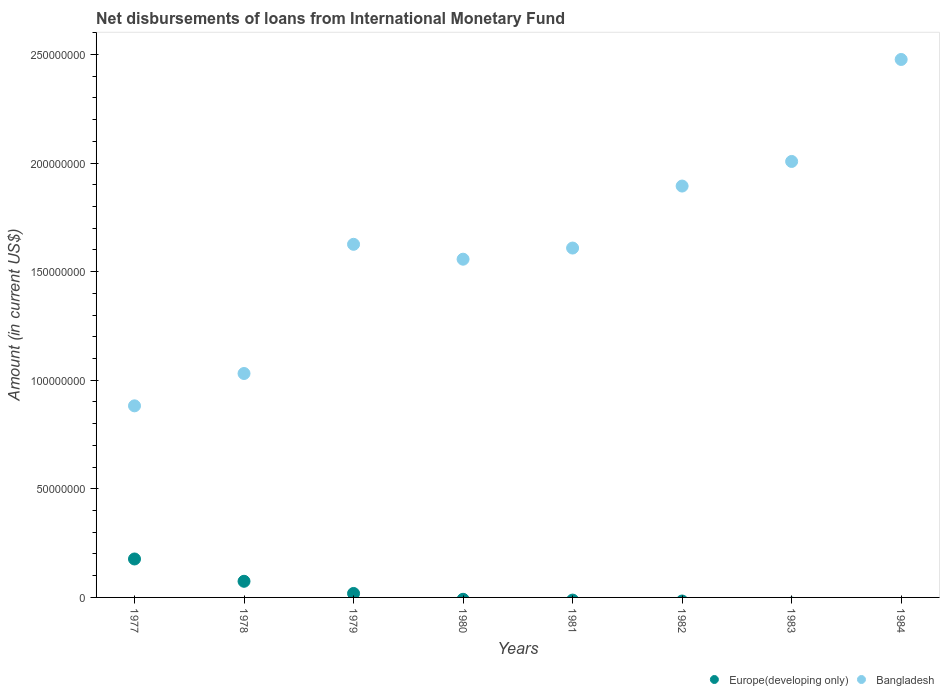How many different coloured dotlines are there?
Keep it short and to the point. 2. Is the number of dotlines equal to the number of legend labels?
Give a very brief answer. No. Across all years, what is the maximum amount of loans disbursed in Bangladesh?
Your answer should be compact. 2.48e+08. In which year was the amount of loans disbursed in Europe(developing only) maximum?
Ensure brevity in your answer.  1977. What is the total amount of loans disbursed in Europe(developing only) in the graph?
Your answer should be compact. 2.70e+07. What is the difference between the amount of loans disbursed in Bangladesh in 1977 and that in 1983?
Your response must be concise. -1.13e+08. What is the difference between the amount of loans disbursed in Bangladesh in 1984 and the amount of loans disbursed in Europe(developing only) in 1979?
Make the answer very short. 2.46e+08. What is the average amount of loans disbursed in Europe(developing only) per year?
Offer a terse response. 3.37e+06. In the year 1979, what is the difference between the amount of loans disbursed in Bangladesh and amount of loans disbursed in Europe(developing only)?
Provide a succinct answer. 1.61e+08. What is the ratio of the amount of loans disbursed in Bangladesh in 1979 to that in 1982?
Your answer should be compact. 0.86. What is the difference between the highest and the second highest amount of loans disbursed in Europe(developing only)?
Offer a very short reply. 1.03e+07. What is the difference between the highest and the lowest amount of loans disbursed in Bangladesh?
Provide a short and direct response. 1.59e+08. Does the amount of loans disbursed in Europe(developing only) monotonically increase over the years?
Offer a very short reply. No. Is the amount of loans disbursed in Europe(developing only) strictly greater than the amount of loans disbursed in Bangladesh over the years?
Your answer should be very brief. No. How many dotlines are there?
Your response must be concise. 2. Does the graph contain any zero values?
Offer a very short reply. Yes. Where does the legend appear in the graph?
Keep it short and to the point. Bottom right. What is the title of the graph?
Offer a terse response. Net disbursements of loans from International Monetary Fund. Does "Samoa" appear as one of the legend labels in the graph?
Your answer should be compact. No. What is the label or title of the X-axis?
Your response must be concise. Years. What is the Amount (in current US$) in Europe(developing only) in 1977?
Keep it short and to the point. 1.77e+07. What is the Amount (in current US$) of Bangladesh in 1977?
Provide a short and direct response. 8.82e+07. What is the Amount (in current US$) in Europe(developing only) in 1978?
Your response must be concise. 7.43e+06. What is the Amount (in current US$) in Bangladesh in 1978?
Your answer should be compact. 1.03e+08. What is the Amount (in current US$) in Europe(developing only) in 1979?
Your answer should be very brief. 1.83e+06. What is the Amount (in current US$) in Bangladesh in 1979?
Keep it short and to the point. 1.63e+08. What is the Amount (in current US$) in Bangladesh in 1980?
Keep it short and to the point. 1.56e+08. What is the Amount (in current US$) in Bangladesh in 1981?
Keep it short and to the point. 1.61e+08. What is the Amount (in current US$) in Europe(developing only) in 1982?
Provide a succinct answer. 0. What is the Amount (in current US$) in Bangladesh in 1982?
Offer a very short reply. 1.89e+08. What is the Amount (in current US$) of Europe(developing only) in 1983?
Provide a short and direct response. 0. What is the Amount (in current US$) of Bangladesh in 1983?
Ensure brevity in your answer.  2.01e+08. What is the Amount (in current US$) in Bangladesh in 1984?
Your response must be concise. 2.48e+08. Across all years, what is the maximum Amount (in current US$) of Europe(developing only)?
Your answer should be very brief. 1.77e+07. Across all years, what is the maximum Amount (in current US$) of Bangladesh?
Offer a terse response. 2.48e+08. Across all years, what is the minimum Amount (in current US$) in Europe(developing only)?
Your response must be concise. 0. Across all years, what is the minimum Amount (in current US$) of Bangladesh?
Your answer should be very brief. 8.82e+07. What is the total Amount (in current US$) in Europe(developing only) in the graph?
Offer a terse response. 2.70e+07. What is the total Amount (in current US$) in Bangladesh in the graph?
Make the answer very short. 1.31e+09. What is the difference between the Amount (in current US$) of Europe(developing only) in 1977 and that in 1978?
Offer a very short reply. 1.03e+07. What is the difference between the Amount (in current US$) in Bangladesh in 1977 and that in 1978?
Keep it short and to the point. -1.49e+07. What is the difference between the Amount (in current US$) in Europe(developing only) in 1977 and that in 1979?
Your response must be concise. 1.59e+07. What is the difference between the Amount (in current US$) of Bangladesh in 1977 and that in 1979?
Provide a short and direct response. -7.44e+07. What is the difference between the Amount (in current US$) of Bangladesh in 1977 and that in 1980?
Give a very brief answer. -6.75e+07. What is the difference between the Amount (in current US$) of Bangladesh in 1977 and that in 1981?
Keep it short and to the point. -7.26e+07. What is the difference between the Amount (in current US$) of Bangladesh in 1977 and that in 1982?
Your response must be concise. -1.01e+08. What is the difference between the Amount (in current US$) in Bangladesh in 1977 and that in 1983?
Provide a succinct answer. -1.13e+08. What is the difference between the Amount (in current US$) in Bangladesh in 1977 and that in 1984?
Keep it short and to the point. -1.59e+08. What is the difference between the Amount (in current US$) in Europe(developing only) in 1978 and that in 1979?
Provide a short and direct response. 5.60e+06. What is the difference between the Amount (in current US$) in Bangladesh in 1978 and that in 1979?
Your response must be concise. -5.95e+07. What is the difference between the Amount (in current US$) in Bangladesh in 1978 and that in 1980?
Your answer should be very brief. -5.26e+07. What is the difference between the Amount (in current US$) of Bangladesh in 1978 and that in 1981?
Your answer should be compact. -5.78e+07. What is the difference between the Amount (in current US$) in Bangladesh in 1978 and that in 1982?
Give a very brief answer. -8.63e+07. What is the difference between the Amount (in current US$) of Bangladesh in 1978 and that in 1983?
Offer a very short reply. -9.76e+07. What is the difference between the Amount (in current US$) in Bangladesh in 1978 and that in 1984?
Your answer should be compact. -1.45e+08. What is the difference between the Amount (in current US$) in Bangladesh in 1979 and that in 1980?
Make the answer very short. 6.85e+06. What is the difference between the Amount (in current US$) of Bangladesh in 1979 and that in 1981?
Your response must be concise. 1.72e+06. What is the difference between the Amount (in current US$) of Bangladesh in 1979 and that in 1982?
Offer a very short reply. -2.68e+07. What is the difference between the Amount (in current US$) in Bangladesh in 1979 and that in 1983?
Make the answer very short. -3.81e+07. What is the difference between the Amount (in current US$) of Bangladesh in 1979 and that in 1984?
Your answer should be very brief. -8.51e+07. What is the difference between the Amount (in current US$) in Bangladesh in 1980 and that in 1981?
Make the answer very short. -5.13e+06. What is the difference between the Amount (in current US$) of Bangladesh in 1980 and that in 1982?
Your response must be concise. -3.37e+07. What is the difference between the Amount (in current US$) in Bangladesh in 1980 and that in 1983?
Your response must be concise. -4.50e+07. What is the difference between the Amount (in current US$) in Bangladesh in 1980 and that in 1984?
Provide a short and direct response. -9.20e+07. What is the difference between the Amount (in current US$) in Bangladesh in 1981 and that in 1982?
Ensure brevity in your answer.  -2.85e+07. What is the difference between the Amount (in current US$) of Bangladesh in 1981 and that in 1983?
Provide a succinct answer. -3.99e+07. What is the difference between the Amount (in current US$) in Bangladesh in 1981 and that in 1984?
Your answer should be compact. -8.68e+07. What is the difference between the Amount (in current US$) of Bangladesh in 1982 and that in 1983?
Offer a terse response. -1.13e+07. What is the difference between the Amount (in current US$) of Bangladesh in 1982 and that in 1984?
Your response must be concise. -5.83e+07. What is the difference between the Amount (in current US$) in Bangladesh in 1983 and that in 1984?
Keep it short and to the point. -4.70e+07. What is the difference between the Amount (in current US$) in Europe(developing only) in 1977 and the Amount (in current US$) in Bangladesh in 1978?
Offer a very short reply. -8.54e+07. What is the difference between the Amount (in current US$) of Europe(developing only) in 1977 and the Amount (in current US$) of Bangladesh in 1979?
Offer a very short reply. -1.45e+08. What is the difference between the Amount (in current US$) in Europe(developing only) in 1977 and the Amount (in current US$) in Bangladesh in 1980?
Provide a short and direct response. -1.38e+08. What is the difference between the Amount (in current US$) in Europe(developing only) in 1977 and the Amount (in current US$) in Bangladesh in 1981?
Provide a short and direct response. -1.43e+08. What is the difference between the Amount (in current US$) in Europe(developing only) in 1977 and the Amount (in current US$) in Bangladesh in 1982?
Offer a very short reply. -1.72e+08. What is the difference between the Amount (in current US$) in Europe(developing only) in 1977 and the Amount (in current US$) in Bangladesh in 1983?
Make the answer very short. -1.83e+08. What is the difference between the Amount (in current US$) of Europe(developing only) in 1977 and the Amount (in current US$) of Bangladesh in 1984?
Your answer should be very brief. -2.30e+08. What is the difference between the Amount (in current US$) of Europe(developing only) in 1978 and the Amount (in current US$) of Bangladesh in 1979?
Keep it short and to the point. -1.55e+08. What is the difference between the Amount (in current US$) in Europe(developing only) in 1978 and the Amount (in current US$) in Bangladesh in 1980?
Offer a terse response. -1.48e+08. What is the difference between the Amount (in current US$) of Europe(developing only) in 1978 and the Amount (in current US$) of Bangladesh in 1981?
Your response must be concise. -1.53e+08. What is the difference between the Amount (in current US$) of Europe(developing only) in 1978 and the Amount (in current US$) of Bangladesh in 1982?
Provide a short and direct response. -1.82e+08. What is the difference between the Amount (in current US$) in Europe(developing only) in 1978 and the Amount (in current US$) in Bangladesh in 1983?
Offer a very short reply. -1.93e+08. What is the difference between the Amount (in current US$) of Europe(developing only) in 1978 and the Amount (in current US$) of Bangladesh in 1984?
Your answer should be very brief. -2.40e+08. What is the difference between the Amount (in current US$) of Europe(developing only) in 1979 and the Amount (in current US$) of Bangladesh in 1980?
Your answer should be compact. -1.54e+08. What is the difference between the Amount (in current US$) of Europe(developing only) in 1979 and the Amount (in current US$) of Bangladesh in 1981?
Ensure brevity in your answer.  -1.59e+08. What is the difference between the Amount (in current US$) in Europe(developing only) in 1979 and the Amount (in current US$) in Bangladesh in 1982?
Your answer should be compact. -1.88e+08. What is the difference between the Amount (in current US$) in Europe(developing only) in 1979 and the Amount (in current US$) in Bangladesh in 1983?
Offer a terse response. -1.99e+08. What is the difference between the Amount (in current US$) of Europe(developing only) in 1979 and the Amount (in current US$) of Bangladesh in 1984?
Offer a terse response. -2.46e+08. What is the average Amount (in current US$) in Europe(developing only) per year?
Your answer should be compact. 3.37e+06. What is the average Amount (in current US$) of Bangladesh per year?
Make the answer very short. 1.64e+08. In the year 1977, what is the difference between the Amount (in current US$) of Europe(developing only) and Amount (in current US$) of Bangladesh?
Provide a succinct answer. -7.05e+07. In the year 1978, what is the difference between the Amount (in current US$) of Europe(developing only) and Amount (in current US$) of Bangladesh?
Make the answer very short. -9.57e+07. In the year 1979, what is the difference between the Amount (in current US$) of Europe(developing only) and Amount (in current US$) of Bangladesh?
Provide a short and direct response. -1.61e+08. What is the ratio of the Amount (in current US$) in Europe(developing only) in 1977 to that in 1978?
Make the answer very short. 2.38. What is the ratio of the Amount (in current US$) of Bangladesh in 1977 to that in 1978?
Ensure brevity in your answer.  0.86. What is the ratio of the Amount (in current US$) of Europe(developing only) in 1977 to that in 1979?
Offer a terse response. 9.69. What is the ratio of the Amount (in current US$) in Bangladesh in 1977 to that in 1979?
Offer a very short reply. 0.54. What is the ratio of the Amount (in current US$) in Bangladesh in 1977 to that in 1980?
Your response must be concise. 0.57. What is the ratio of the Amount (in current US$) in Bangladesh in 1977 to that in 1981?
Your answer should be compact. 0.55. What is the ratio of the Amount (in current US$) in Bangladesh in 1977 to that in 1982?
Your answer should be very brief. 0.47. What is the ratio of the Amount (in current US$) in Bangladesh in 1977 to that in 1983?
Offer a very short reply. 0.44. What is the ratio of the Amount (in current US$) in Bangladesh in 1977 to that in 1984?
Your answer should be compact. 0.36. What is the ratio of the Amount (in current US$) in Europe(developing only) in 1978 to that in 1979?
Ensure brevity in your answer.  4.07. What is the ratio of the Amount (in current US$) of Bangladesh in 1978 to that in 1979?
Give a very brief answer. 0.63. What is the ratio of the Amount (in current US$) of Bangladesh in 1978 to that in 1980?
Keep it short and to the point. 0.66. What is the ratio of the Amount (in current US$) in Bangladesh in 1978 to that in 1981?
Make the answer very short. 0.64. What is the ratio of the Amount (in current US$) in Bangladesh in 1978 to that in 1982?
Offer a terse response. 0.54. What is the ratio of the Amount (in current US$) in Bangladesh in 1978 to that in 1983?
Your response must be concise. 0.51. What is the ratio of the Amount (in current US$) in Bangladesh in 1978 to that in 1984?
Give a very brief answer. 0.42. What is the ratio of the Amount (in current US$) in Bangladesh in 1979 to that in 1980?
Offer a very short reply. 1.04. What is the ratio of the Amount (in current US$) in Bangladesh in 1979 to that in 1981?
Your answer should be very brief. 1.01. What is the ratio of the Amount (in current US$) of Bangladesh in 1979 to that in 1982?
Keep it short and to the point. 0.86. What is the ratio of the Amount (in current US$) in Bangladesh in 1979 to that in 1983?
Provide a succinct answer. 0.81. What is the ratio of the Amount (in current US$) in Bangladesh in 1979 to that in 1984?
Provide a succinct answer. 0.66. What is the ratio of the Amount (in current US$) of Bangladesh in 1980 to that in 1981?
Your answer should be very brief. 0.97. What is the ratio of the Amount (in current US$) in Bangladesh in 1980 to that in 1982?
Provide a succinct answer. 0.82. What is the ratio of the Amount (in current US$) of Bangladesh in 1980 to that in 1983?
Provide a succinct answer. 0.78. What is the ratio of the Amount (in current US$) of Bangladesh in 1980 to that in 1984?
Ensure brevity in your answer.  0.63. What is the ratio of the Amount (in current US$) in Bangladesh in 1981 to that in 1982?
Offer a very short reply. 0.85. What is the ratio of the Amount (in current US$) of Bangladesh in 1981 to that in 1983?
Provide a succinct answer. 0.8. What is the ratio of the Amount (in current US$) in Bangladesh in 1981 to that in 1984?
Offer a very short reply. 0.65. What is the ratio of the Amount (in current US$) in Bangladesh in 1982 to that in 1983?
Give a very brief answer. 0.94. What is the ratio of the Amount (in current US$) in Bangladesh in 1982 to that in 1984?
Offer a very short reply. 0.76. What is the ratio of the Amount (in current US$) in Bangladesh in 1983 to that in 1984?
Offer a very short reply. 0.81. What is the difference between the highest and the second highest Amount (in current US$) in Europe(developing only)?
Ensure brevity in your answer.  1.03e+07. What is the difference between the highest and the second highest Amount (in current US$) in Bangladesh?
Provide a short and direct response. 4.70e+07. What is the difference between the highest and the lowest Amount (in current US$) of Europe(developing only)?
Make the answer very short. 1.77e+07. What is the difference between the highest and the lowest Amount (in current US$) of Bangladesh?
Give a very brief answer. 1.59e+08. 